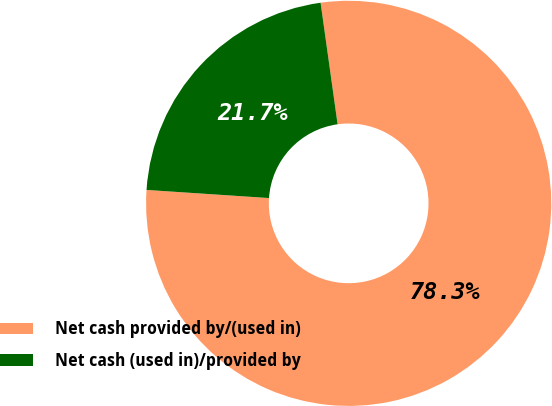Convert chart. <chart><loc_0><loc_0><loc_500><loc_500><pie_chart><fcel>Net cash provided by/(used in)<fcel>Net cash (used in)/provided by<nl><fcel>78.27%<fcel>21.73%<nl></chart> 